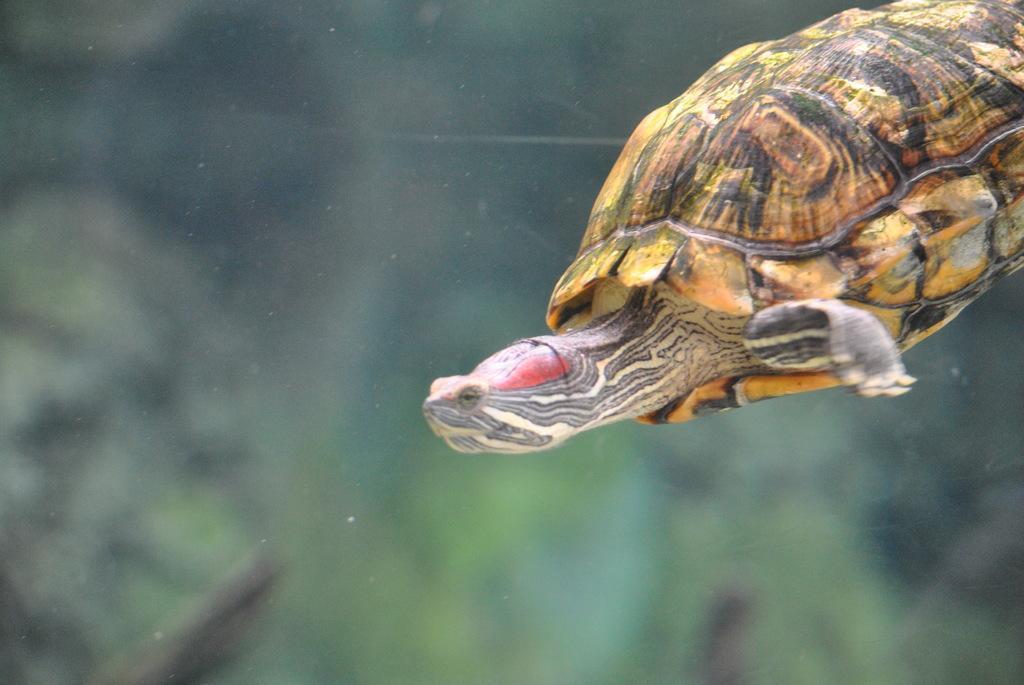How would you summarize this image in a sentence or two? This image consists of a turtle. It looks like it is clicked in the water. The background is blurred. 